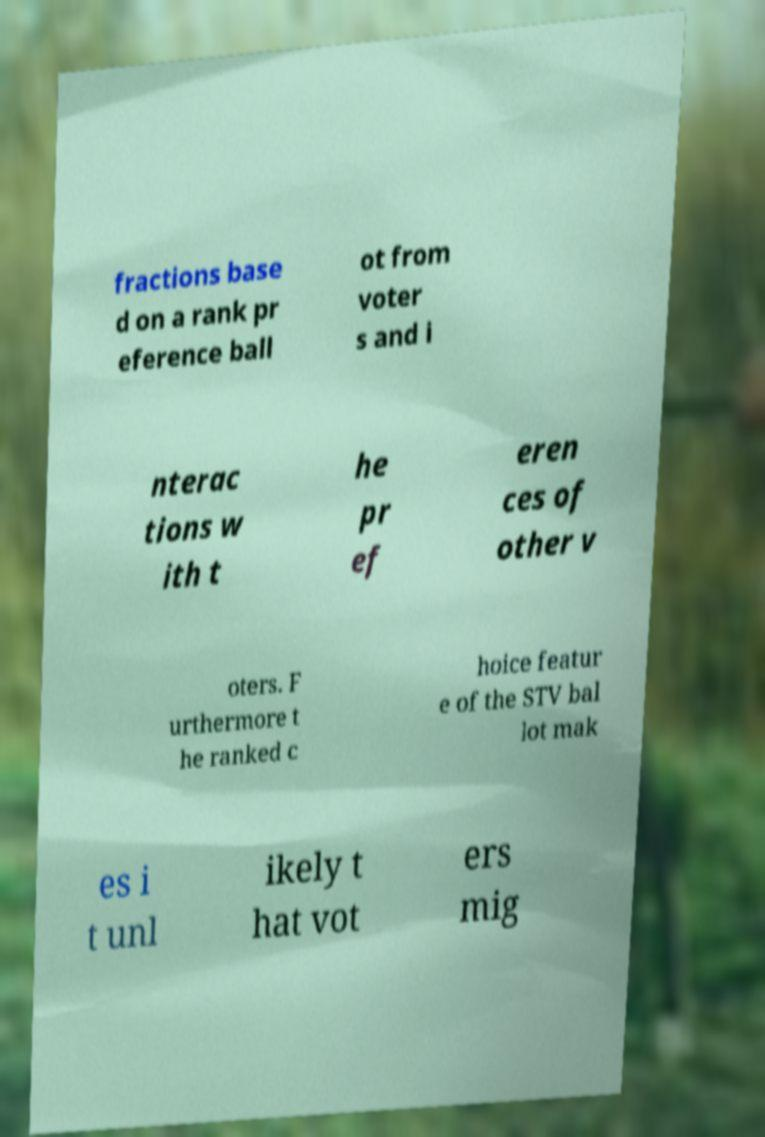Can you read and provide the text displayed in the image?This photo seems to have some interesting text. Can you extract and type it out for me? fractions base d on a rank pr eference ball ot from voter s and i nterac tions w ith t he pr ef eren ces of other v oters. F urthermore t he ranked c hoice featur e of the STV bal lot mak es i t unl ikely t hat vot ers mig 